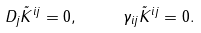<formula> <loc_0><loc_0><loc_500><loc_500>D _ { j } \tilde { K } ^ { i j } = 0 , \text { \quad } \gamma _ { i j } \tilde { K } ^ { i j } = 0 .</formula> 